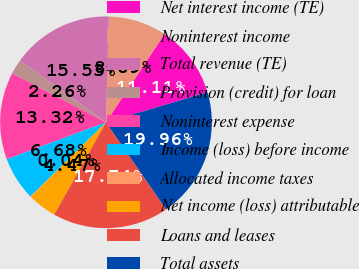<chart> <loc_0><loc_0><loc_500><loc_500><pie_chart><fcel>Net interest income (TE)<fcel>Noninterest income<fcel>Total revenue (TE)<fcel>Provision (credit) for loan<fcel>Noninterest expense<fcel>Income (loss) before income<fcel>Allocated income taxes<fcel>Net income (loss) attributable<fcel>Loans and leases<fcel>Total assets<nl><fcel>11.11%<fcel>8.89%<fcel>15.53%<fcel>2.26%<fcel>13.32%<fcel>6.68%<fcel>0.04%<fcel>4.47%<fcel>17.74%<fcel>19.96%<nl></chart> 